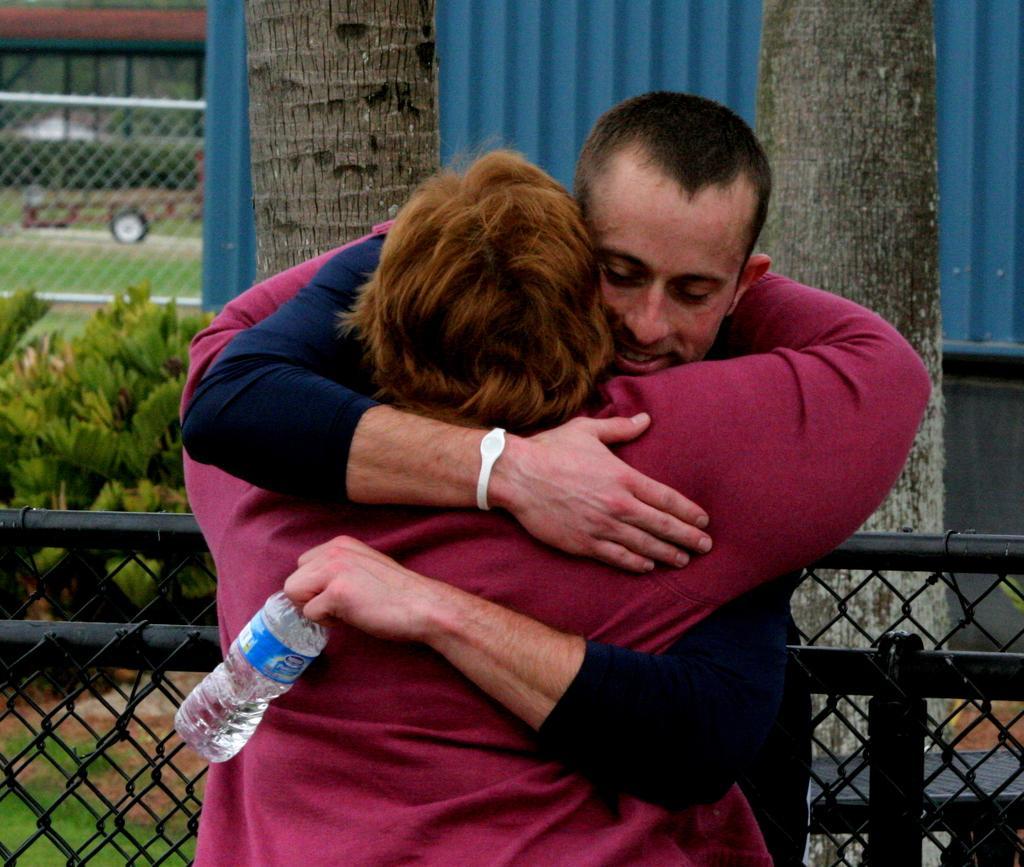Describe this image in one or two sentences. These 2 persons are hugging each-other. This man is holding a bottle. This fence is in black color. Far there is a grass. These are plants. 